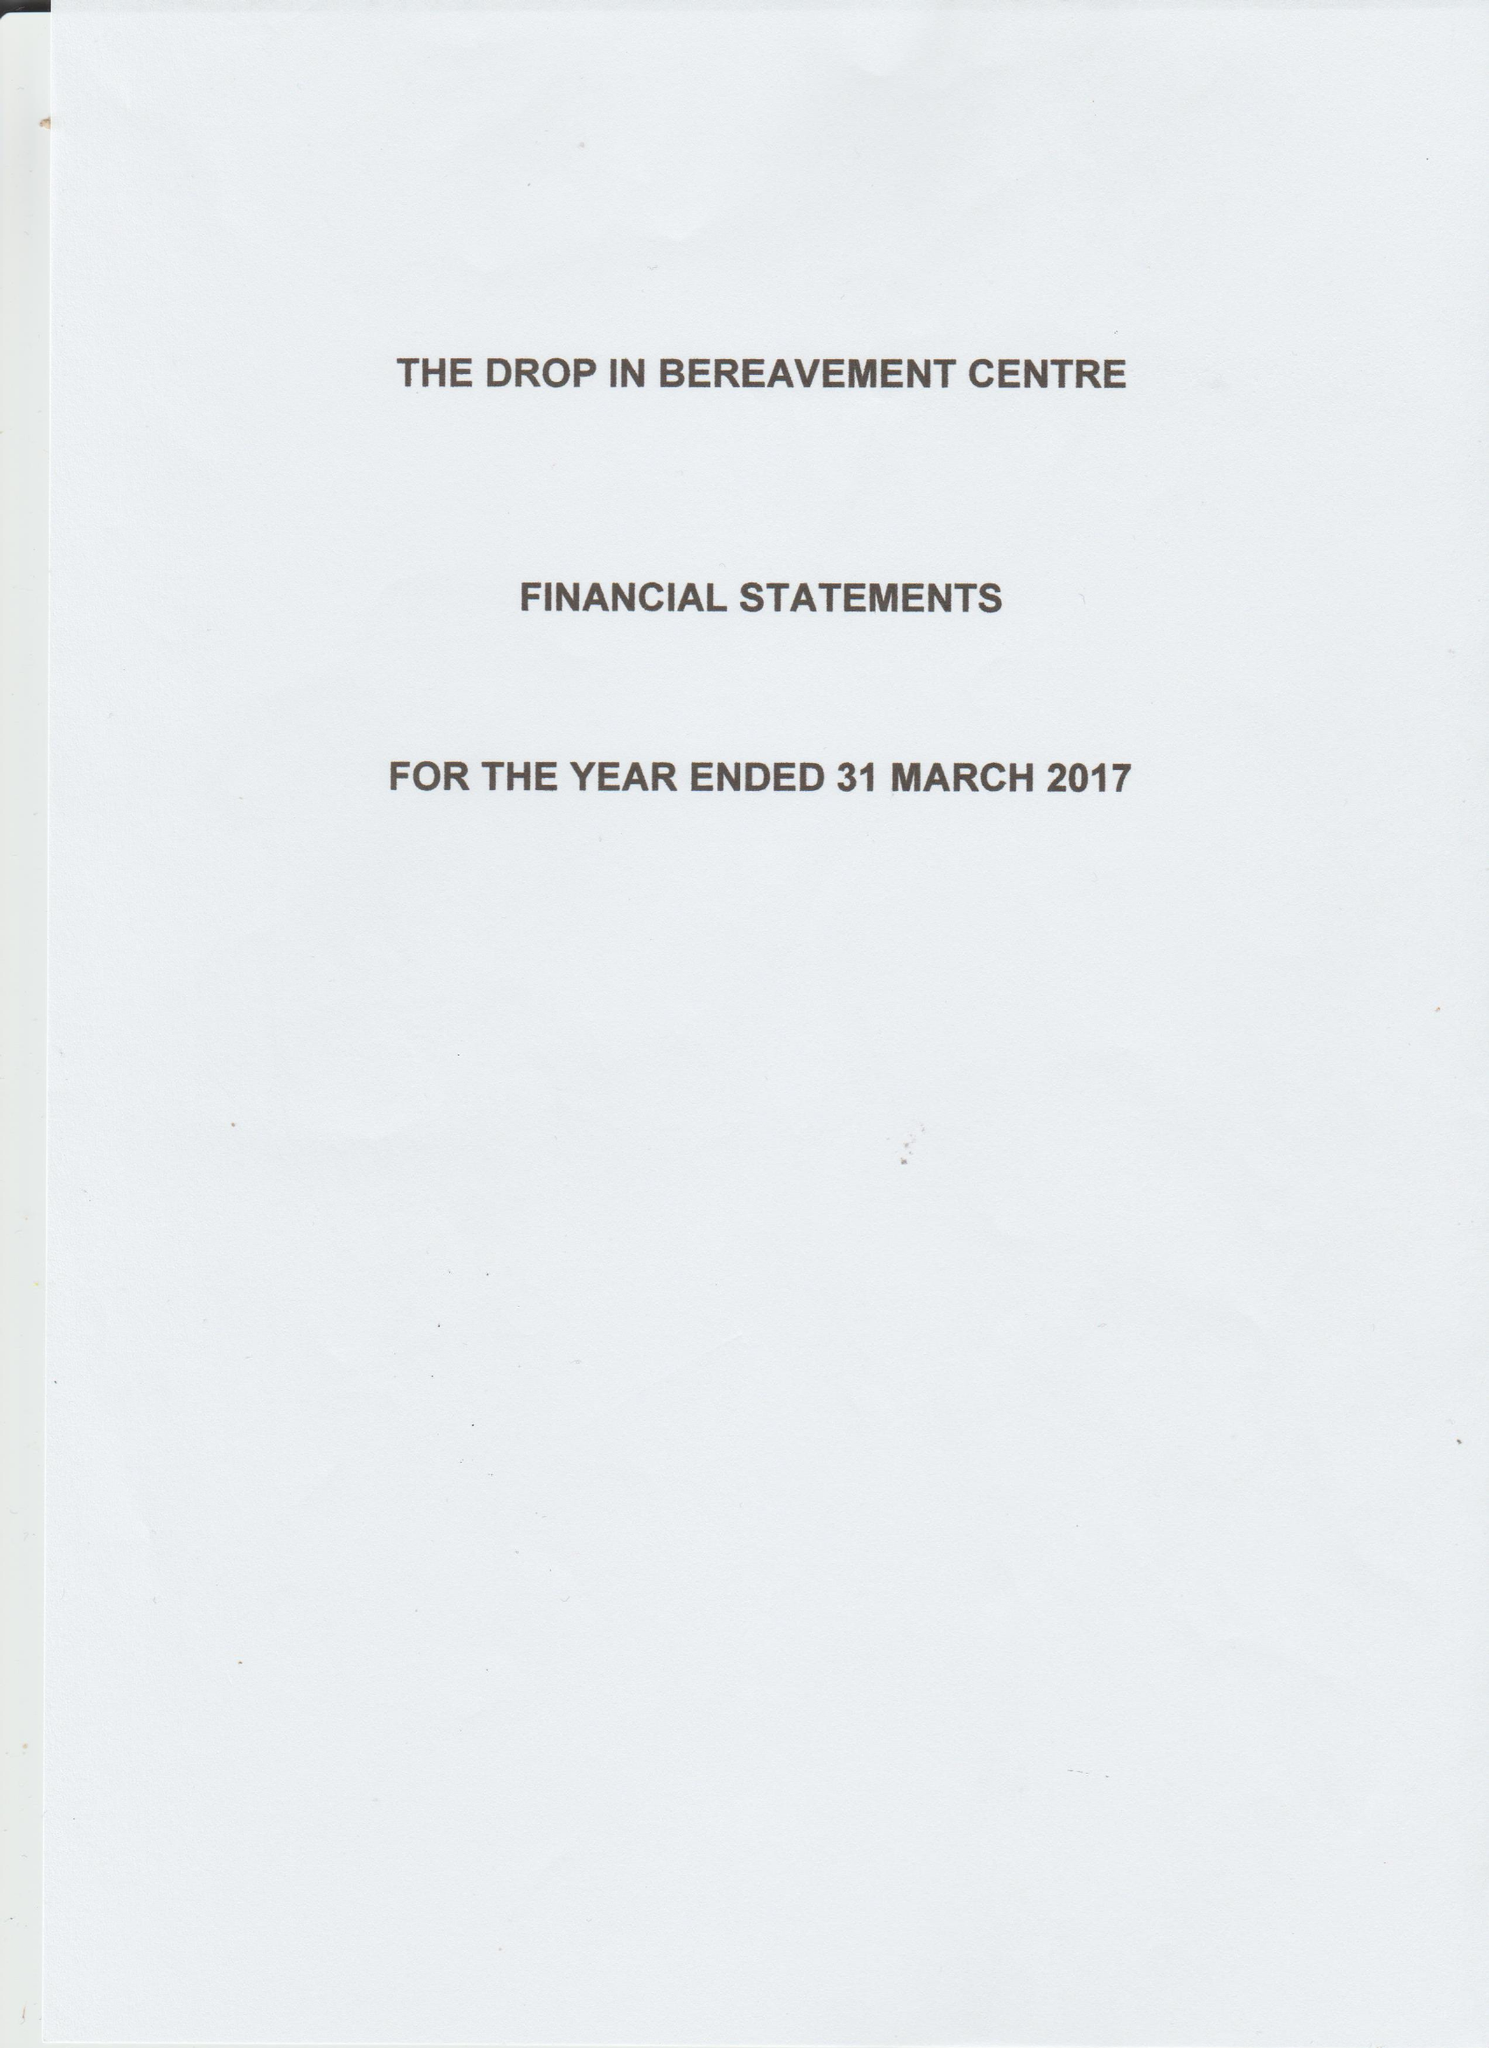What is the value for the address__street_line?
Answer the question using a single word or phrase. 187 GRANGE ROAD 